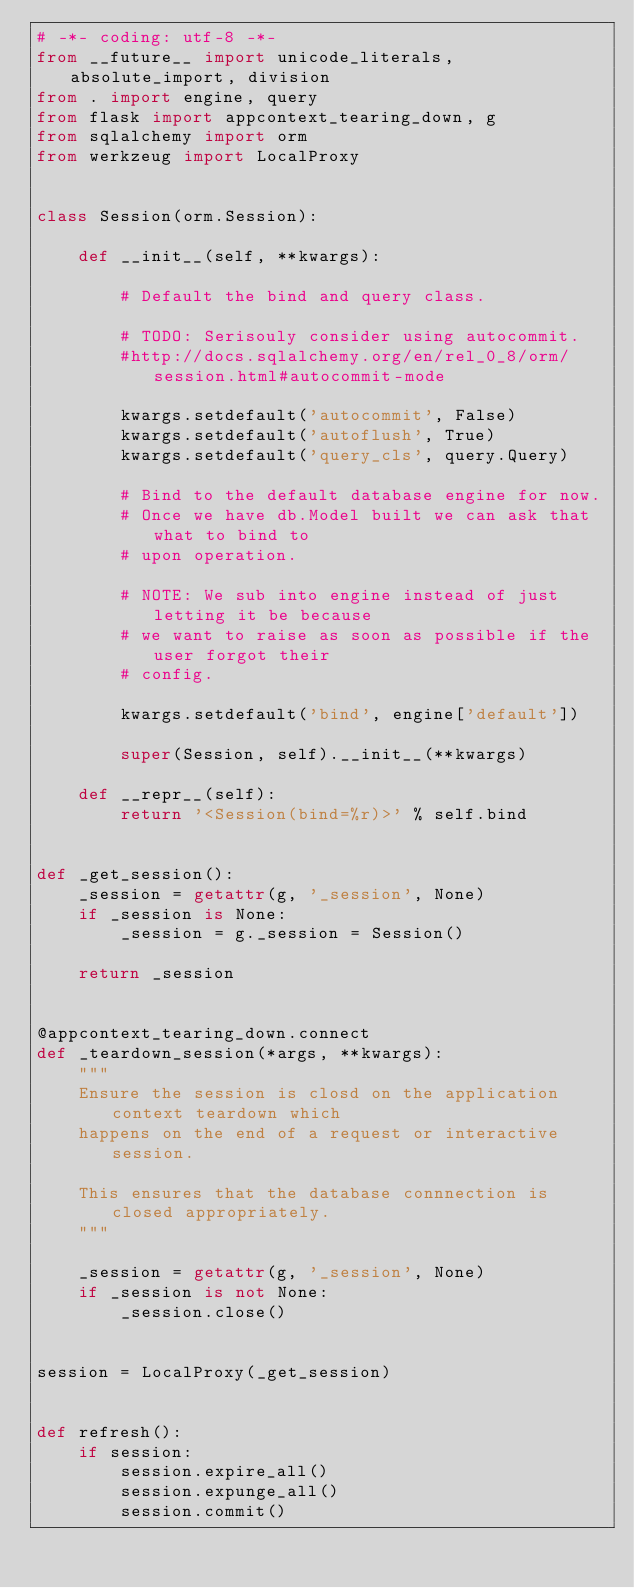<code> <loc_0><loc_0><loc_500><loc_500><_Python_># -*- coding: utf-8 -*-
from __future__ import unicode_literals, absolute_import, division
from . import engine, query
from flask import appcontext_tearing_down, g
from sqlalchemy import orm
from werkzeug import LocalProxy


class Session(orm.Session):

    def __init__(self, **kwargs):

        # Default the bind and query class.

        # TODO: Serisouly consider using autocommit.
        #http://docs.sqlalchemy.org/en/rel_0_8/orm/session.html#autocommit-mode

        kwargs.setdefault('autocommit', False)
        kwargs.setdefault('autoflush', True)
        kwargs.setdefault('query_cls', query.Query)

        # Bind to the default database engine for now.
        # Once we have db.Model built we can ask that what to bind to
        # upon operation.

        # NOTE: We sub into engine instead of just letting it be because
        # we want to raise as soon as possible if the user forgot their
        # config.

        kwargs.setdefault('bind', engine['default'])

        super(Session, self).__init__(**kwargs)

    def __repr__(self):
        return '<Session(bind=%r)>' % self.bind


def _get_session():
    _session = getattr(g, '_session', None)
    if _session is None:
        _session = g._session = Session()

    return _session


@appcontext_tearing_down.connect
def _teardown_session(*args, **kwargs):
    """
    Ensure the session is closd on the application context teardown which
    happens on the end of a request or interactive session.

    This ensures that the database connnection is closed appropriately.
    """

    _session = getattr(g, '_session', None)
    if _session is not None:
        _session.close()


session = LocalProxy(_get_session)


def refresh():
    if session:
        session.expire_all()
        session.expunge_all()
        session.commit()
</code> 